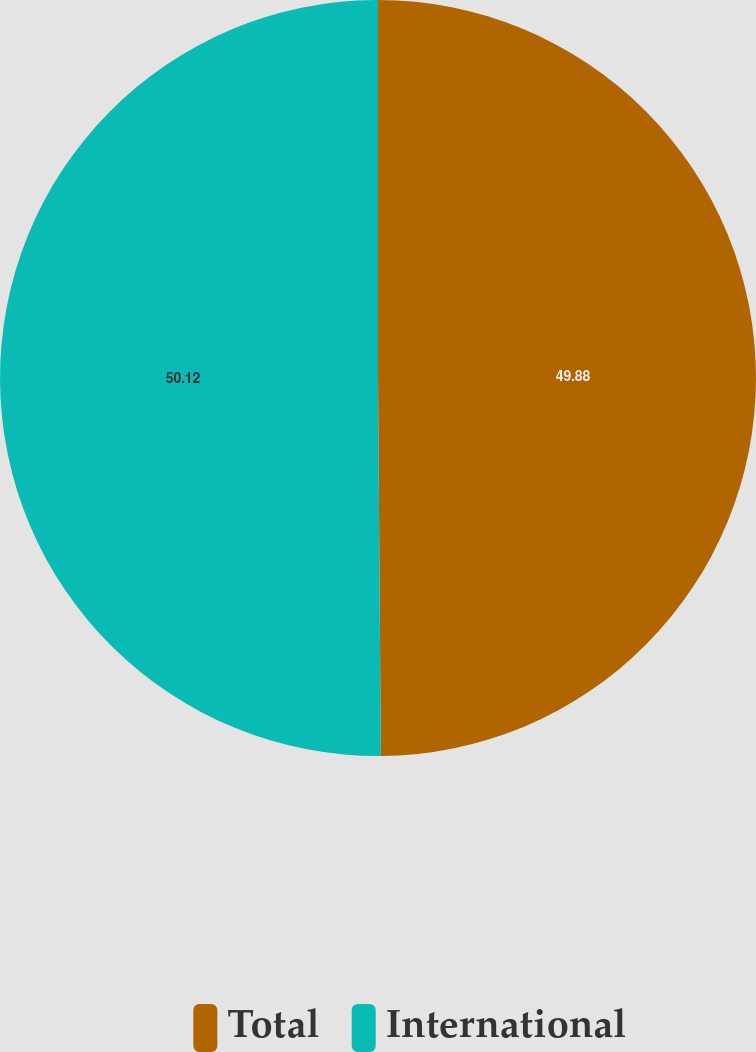<chart> <loc_0><loc_0><loc_500><loc_500><pie_chart><fcel>Total<fcel>International<nl><fcel>49.88%<fcel>50.12%<nl></chart> 